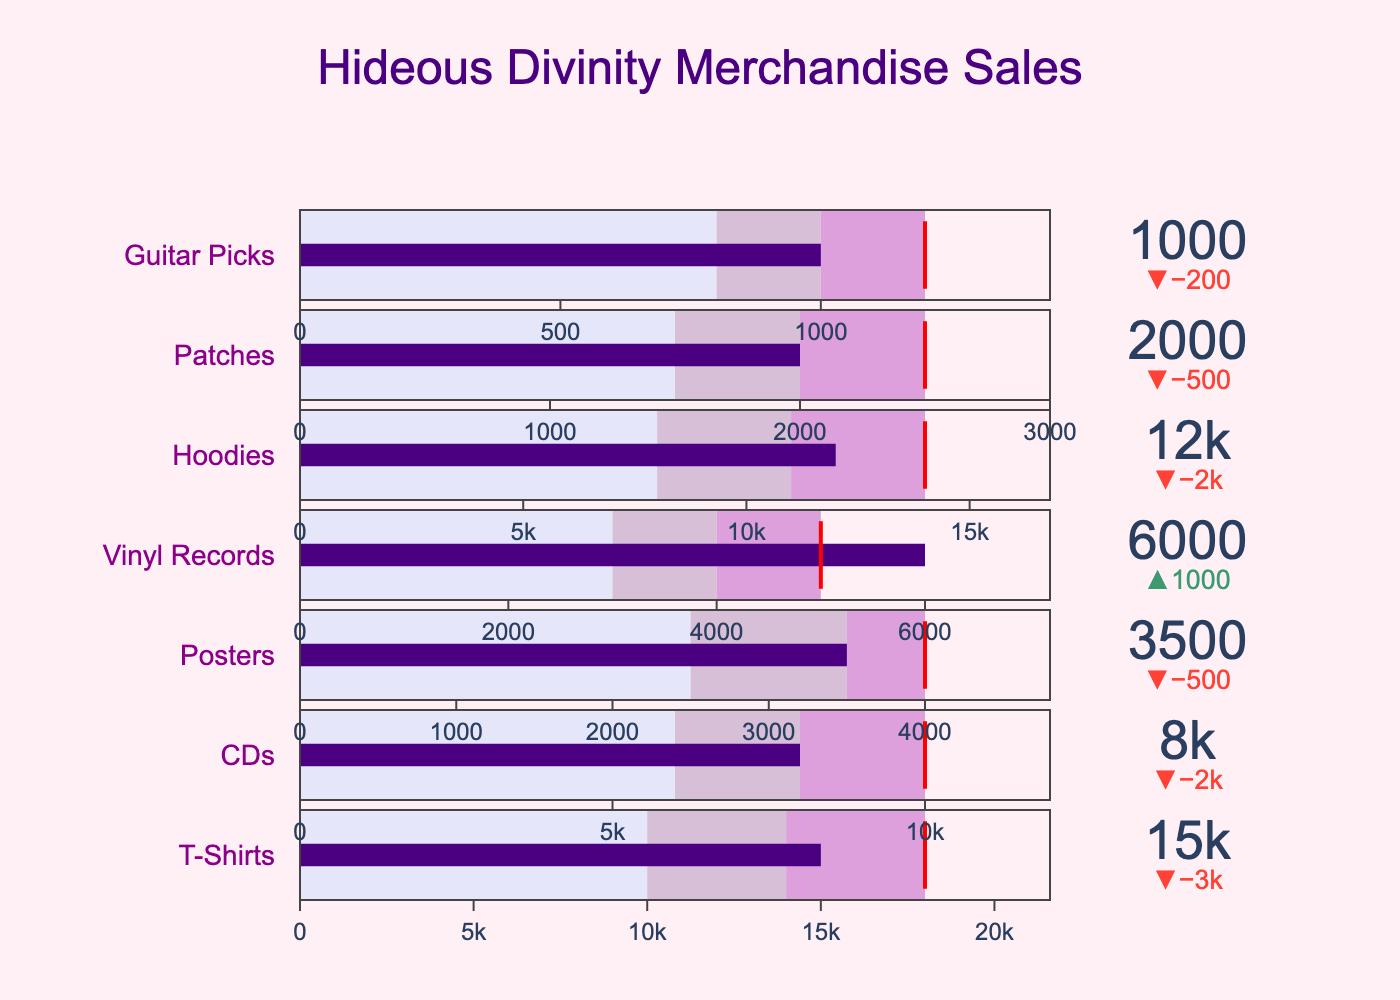what is the title of the figure? The title of the figure is displayed at the top and provides a summary of the data being presented. Here, it reads "Hideous Divinity Merchandise Sales".
Answer: Hideous Divinity Merchandise Sales which category exceeds its revenue target? Look for the categories where the "Actual" value is higher than the "Target" value. In the figure, the "Actual" bar that goes beyond the threshold line designates this.
Answer: Vinyl Records What are the colors of the three ranges in the bullet charts? Refer to the legend or color coding at the base of each bullet chart range. The colors are likely shades of purple and lavender.
Answer: Light Lavender, Lavender, Orchid how much is the actual revenue for the category "CDs"? Locate the "CDs" row in the figure, then identify the "Actual" value indicated on the bar within the bullet chart for this category.
Answer: 8000 what is the difference between the target and actual sales for "Hoodies"? Note the "Actual" and "Target" sales values for Hoodies from the figure. The "Actual" is 12000 and the "Target" is 14000, so the difference is 14000 - 12000.
Answer: 2000 which category has the lowest actual revenue? Compare the "Actual" values for all categories and identify the smallest figure. Here, "Guitar Picks" has the lowest actual revenue of 1000.
Answer: Guitar Picks What categories met their revenue target exactly? Check for categories where the "Actual" value equals the "Target" value by looking at where the bar and threshold marker coincide exactly. No category meets this criterion in the figure.
Answer: None how much more actual revenue did "T-Shirts" have compared to "Posters"? First, note the actual revenue for "T-Shirts" (15000) and "Posters" (3500). Then subtract the latter from the former, i.e., 15000 - 3500.
Answer: 11500 What is the threshold value for "Patches"? Locate the "Patches" row in the figure, then identify the red threshold line which shows the target value.
Answer: 2500 What is the average actual revenue for "Hoodies" and "CDs"? First, find the actual revenue values for "Hoodies" (12000) and "CDs" (8000). Add the two values together, then divide by 2 to find the average, i.e., (12000 + 8000) / 2.
Answer: 10000 